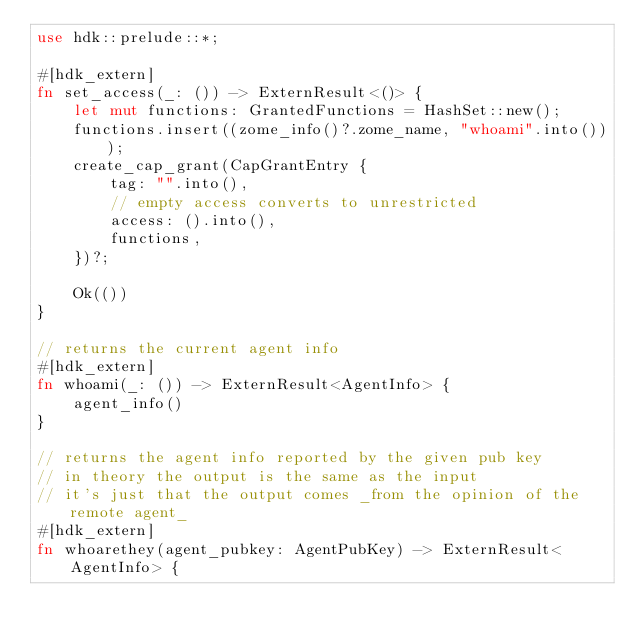Convert code to text. <code><loc_0><loc_0><loc_500><loc_500><_Rust_>use hdk::prelude::*;

#[hdk_extern]
fn set_access(_: ()) -> ExternResult<()> {
    let mut functions: GrantedFunctions = HashSet::new();
    functions.insert((zome_info()?.zome_name, "whoami".into()));
    create_cap_grant(CapGrantEntry {
        tag: "".into(),
        // empty access converts to unrestricted
        access: ().into(),
        functions,
    })?;

    Ok(())
}

// returns the current agent info
#[hdk_extern]
fn whoami(_: ()) -> ExternResult<AgentInfo> {
    agent_info()
}

// returns the agent info reported by the given pub key
// in theory the output is the same as the input
// it's just that the output comes _from the opinion of the remote agent_
#[hdk_extern]
fn whoarethey(agent_pubkey: AgentPubKey) -> ExternResult<AgentInfo> {</code> 